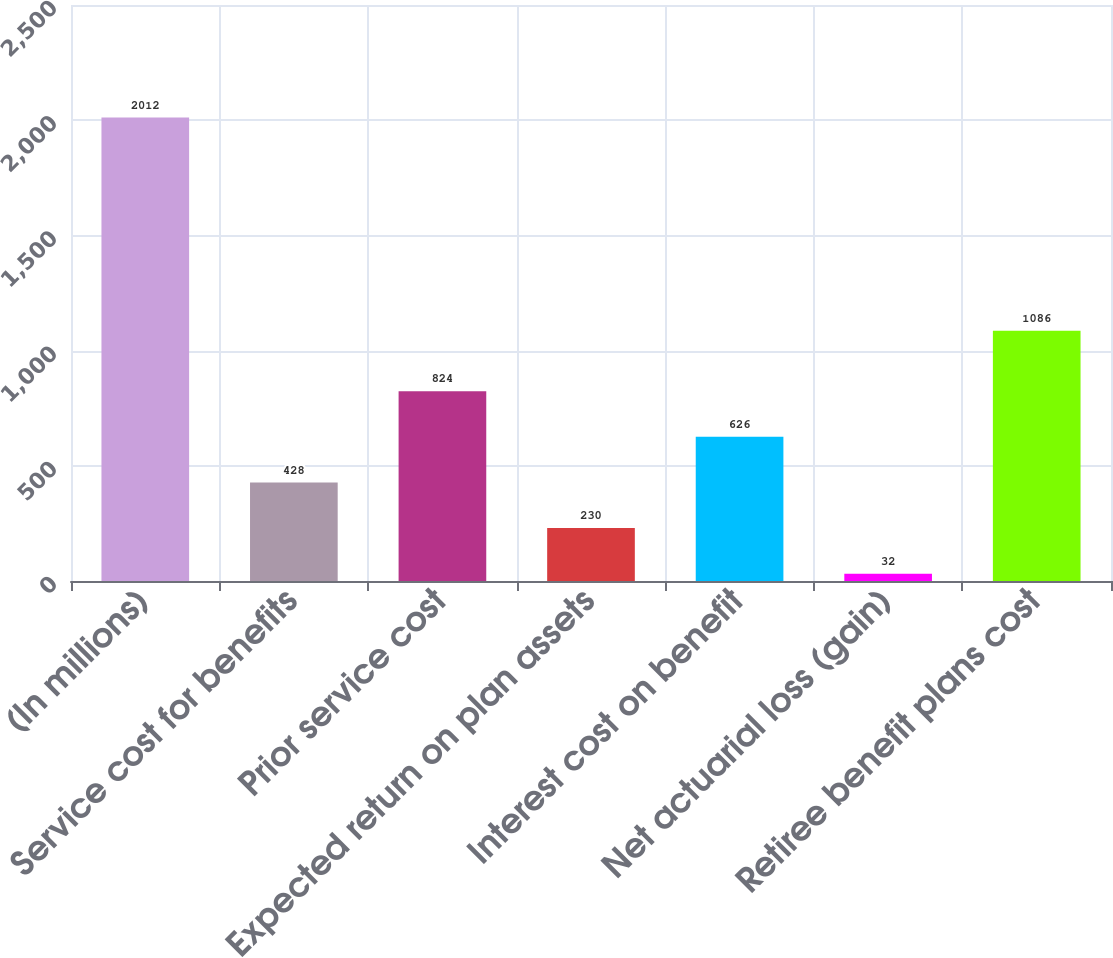Convert chart to OTSL. <chart><loc_0><loc_0><loc_500><loc_500><bar_chart><fcel>(In millions)<fcel>Service cost for benefits<fcel>Prior service cost<fcel>Expected return on plan assets<fcel>Interest cost on benefit<fcel>Net actuarial loss (gain)<fcel>Retiree benefit plans cost<nl><fcel>2012<fcel>428<fcel>824<fcel>230<fcel>626<fcel>32<fcel>1086<nl></chart> 